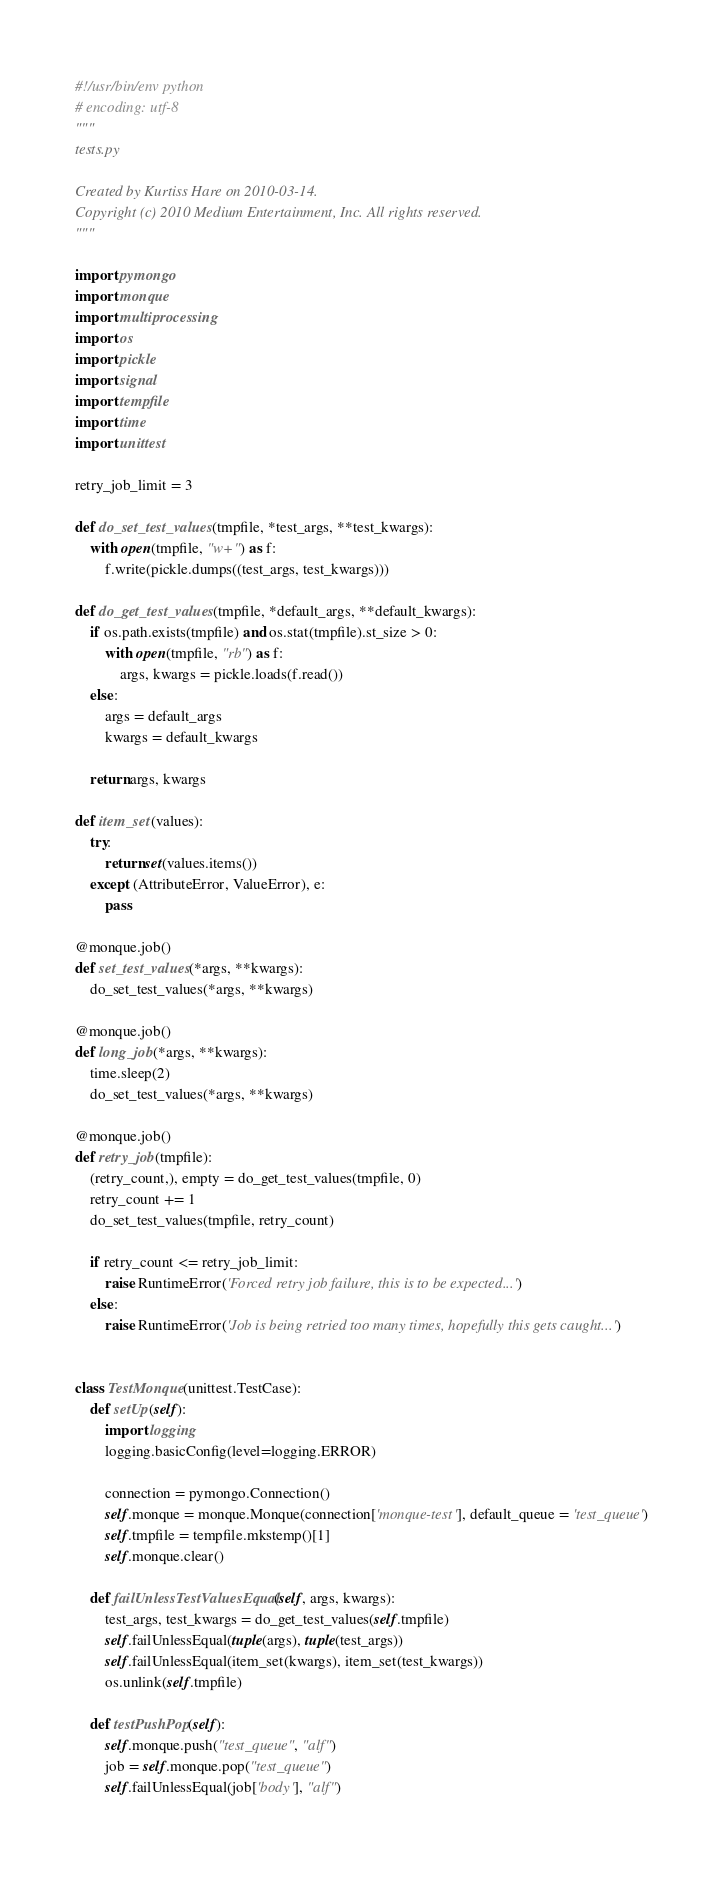Convert code to text. <code><loc_0><loc_0><loc_500><loc_500><_Python_>#!/usr/bin/env python
# encoding: utf-8
"""
tests.py

Created by Kurtiss Hare on 2010-03-14.
Copyright (c) 2010 Medium Entertainment, Inc. All rights reserved.
"""

import pymongo
import monque
import multiprocessing
import os
import pickle
import signal
import tempfile
import time
import unittest

retry_job_limit = 3

def do_set_test_values(tmpfile, *test_args, **test_kwargs):
    with open(tmpfile, "w+") as f:
        f.write(pickle.dumps((test_args, test_kwargs)))

def do_get_test_values(tmpfile, *default_args, **default_kwargs):
    if os.path.exists(tmpfile) and os.stat(tmpfile).st_size > 0:
        with open(tmpfile, "rb") as f:
            args, kwargs = pickle.loads(f.read())
    else:
        args = default_args
        kwargs = default_kwargs

    return args, kwargs
    
def item_set(values):
    try:
        return set(values.items())
    except (AttributeError, ValueError), e:
        pass

@monque.job()
def set_test_values(*args, **kwargs):
    do_set_test_values(*args, **kwargs)

@monque.job()
def long_job(*args, **kwargs):
    time.sleep(2)
    do_set_test_values(*args, **kwargs) 

@monque.job()
def retry_job(tmpfile):
    (retry_count,), empty = do_get_test_values(tmpfile, 0)
    retry_count += 1
    do_set_test_values(tmpfile, retry_count)

    if retry_count <= retry_job_limit:
        raise RuntimeError('Forced retry job failure, this is to be expected...')
    else:
        raise RuntimeError('Job is being retried too many times, hopefully this gets caught...')


class TestMonque(unittest.TestCase):
    def setUp(self):
        import logging
        logging.basicConfig(level=logging.ERROR)

        connection = pymongo.Connection()
        self.monque = monque.Monque(connection['monque-test'], default_queue = 'test_queue')
        self.tmpfile = tempfile.mkstemp()[1]
        self.monque.clear()
    
    def failUnlessTestValuesEqual(self, args, kwargs):
        test_args, test_kwargs = do_get_test_values(self.tmpfile)
        self.failUnlessEqual(tuple(args), tuple(test_args))
        self.failUnlessEqual(item_set(kwargs), item_set(test_kwargs))
        os.unlink(self.tmpfile)
    
    def testPushPop(self):
        self.monque.push("test_queue", "alf")
        job = self.monque.pop("test_queue")
        self.failUnlessEqual(job['body'], "alf")
    </code> 